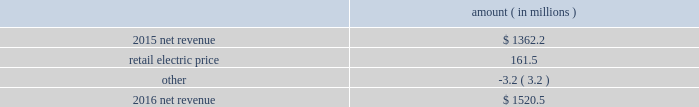Entergy arkansas , inc .
And subsidiaries management 2019s financial discussion and analysis results of operations net income 2016 compared to 2015 net income increased $ 92.9 million primarily due to higher net revenue and lower other operation and maintenance expenses , partially offset by a higher effective income tax rate and higher depreciation and amortization expenses .
2015 compared to 2014 net income decreased $ 47.1 million primarily due to higher other operation and maintenance expenses , partially offset by higher net revenue .
Net revenue 2016 compared to 2015 net revenue consists of operating revenues net of : 1 ) fuel , fuel-related expenses , and gas purchased for resale , 2 ) purchased power expenses , and 3 ) other regulatory charges ( credits ) .
Following is an analysis of the change in net revenue comparing 2016 to 2015 .
Amount ( in millions ) .
The retail electric price variance is primarily due to an increase in base rates , as approved by the apsc .
The new base rates were effective february 24 , 2016 and began billing with the first billing cycle of april 2016 .
The increase includes an interim base rate adjustment surcharge , effective with the first billing cycle of april 2016 , to recover the incremental revenue requirement for the period february 24 , 2016 through march 31 , 2016 .
A significant portion of the increase is related to the purchase of power block 2 of the union power station .
See note 2 to the financial statements for further discussion of the rate case .
See note 14 to the financial statements for further discussion of the union power station purchase. .
What is the net change in net revenue during 2016 for entergy arkansas , inc.? 
Computations: (1520.5 - 1362.2)
Answer: 158.3. 